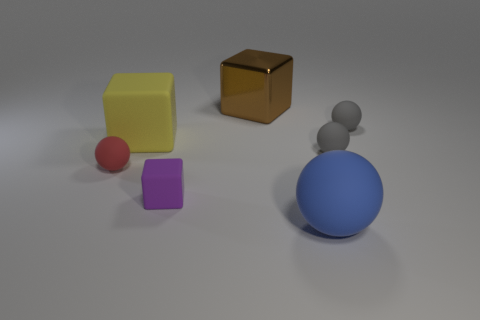What color is the other large matte thing that is the same shape as the red rubber object?
Make the answer very short. Blue. Are there any other things that have the same shape as the small red object?
Make the answer very short. Yes. Are there the same number of yellow matte objects behind the brown metallic thing and tiny brown shiny spheres?
Offer a terse response. Yes. What number of matte objects are both left of the small purple matte block and on the right side of the small red matte ball?
Keep it short and to the point. 1. There is a metallic object that is the same shape as the yellow matte object; what is its size?
Make the answer very short. Large. How many yellow cubes have the same material as the blue object?
Make the answer very short. 1. Is the number of big yellow blocks that are on the left side of the big yellow rubber block less than the number of big yellow rubber cubes?
Offer a very short reply. Yes. How many big blue rubber things are there?
Provide a succinct answer. 1. Do the yellow object and the tiny red thing have the same shape?
Keep it short and to the point. No. There is a cube in front of the red matte sphere that is to the left of the large blue sphere; how big is it?
Make the answer very short. Small. 